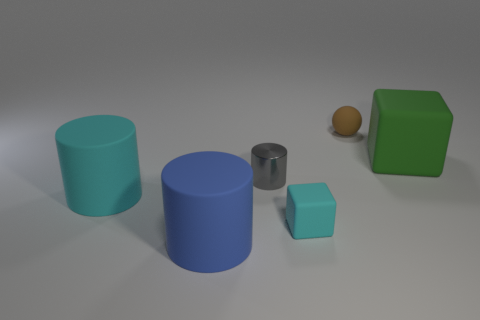What can you infer about the light source in this scene? The shadows suggest that the light source is above and slightly to the right of the arrangement of objects, casting diffuse shadows to the lower left sides of each object, indicating there might be a singular light source akin to an overhead lamp. 